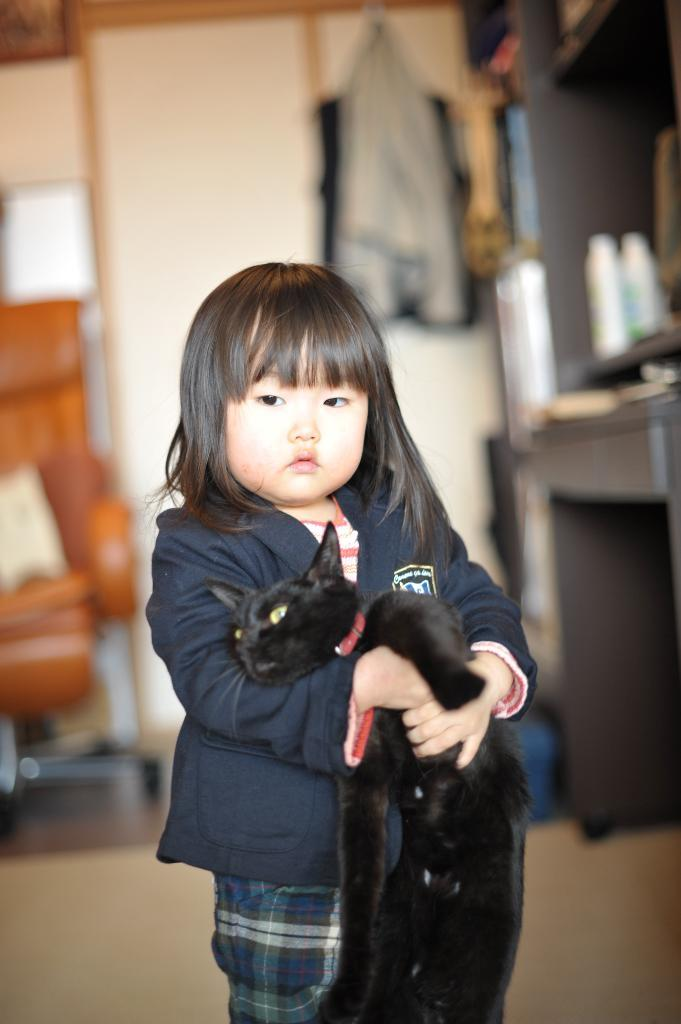Who is the main subject in the picture? There is a little girl in the picture. What is the girl wearing? The girl is wearing a blue jacket. What is the girl holding in her hand? The girl is holding a black cat in her hand. What type of kite is the girl flying in the picture? There is no kite present in the image; the girl is holding a black cat. How does the potato contribute to the scene in the picture? There is no potato present in the image; the main subjects are the little girl and the black cat. 